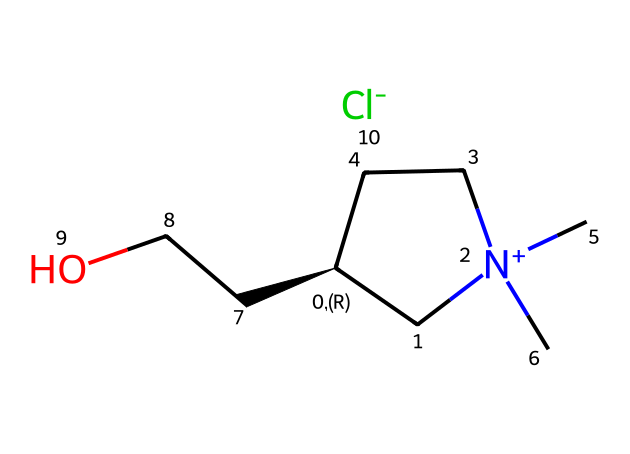What is the primary cation in this ionic liquid? The chemical structure indicates the presence of a nitrogen atom with a positive charge, along with carbon chains connected to it. The cation is thus identified as a quaternary ammonium cation due to its positively charged nitrogen.
Answer: quaternary ammonium cation How many carbon atoms are present in this ionic liquid? By examining the SMILES representation, we can count the carbon atoms. There are five carbon atoms in the chain and attached groups, which are clearly denoted in the structure.
Answer: five What role does the chloride ion play in this ionic liquid? The chloride ion acts as the anion that balances the positive charge from the cation, thus forming a stable ionic liquid structure. The presence of a halide ion contributes to the ionic nature and influences properties such as viscosity and melting point.
Answer: anion What type of interaction primarily occurs between the cation and anion in ionic liquids? The interaction is an ionic bond, characterized by the attraction between the positively charged cation (quaternary ammonium) and the negatively charged anion (chloride). This bond is a primary feature of ionic liquids, giving them unique properties.
Answer: ionic bond How does the presence of the alcohol group affect the properties of this ionic liquid? The alcohol group, indicated by "CCO" in the structure, introduces hydrogen bonding potential, which can enhance solubility and modify the viscosity of the ionic liquid. Such modifications can improve its efficacy in applications like tuning violin strings by altering sound properties.
Answer: modifies properties How many hydrogen atoms are attached to the cation? By analyzing the structure, we can identify that the cation has a total of 15 hydrogen atoms based on the carbon and the nitrogen’s bonding patterns, including those from the attached groups.
Answer: fifteen 